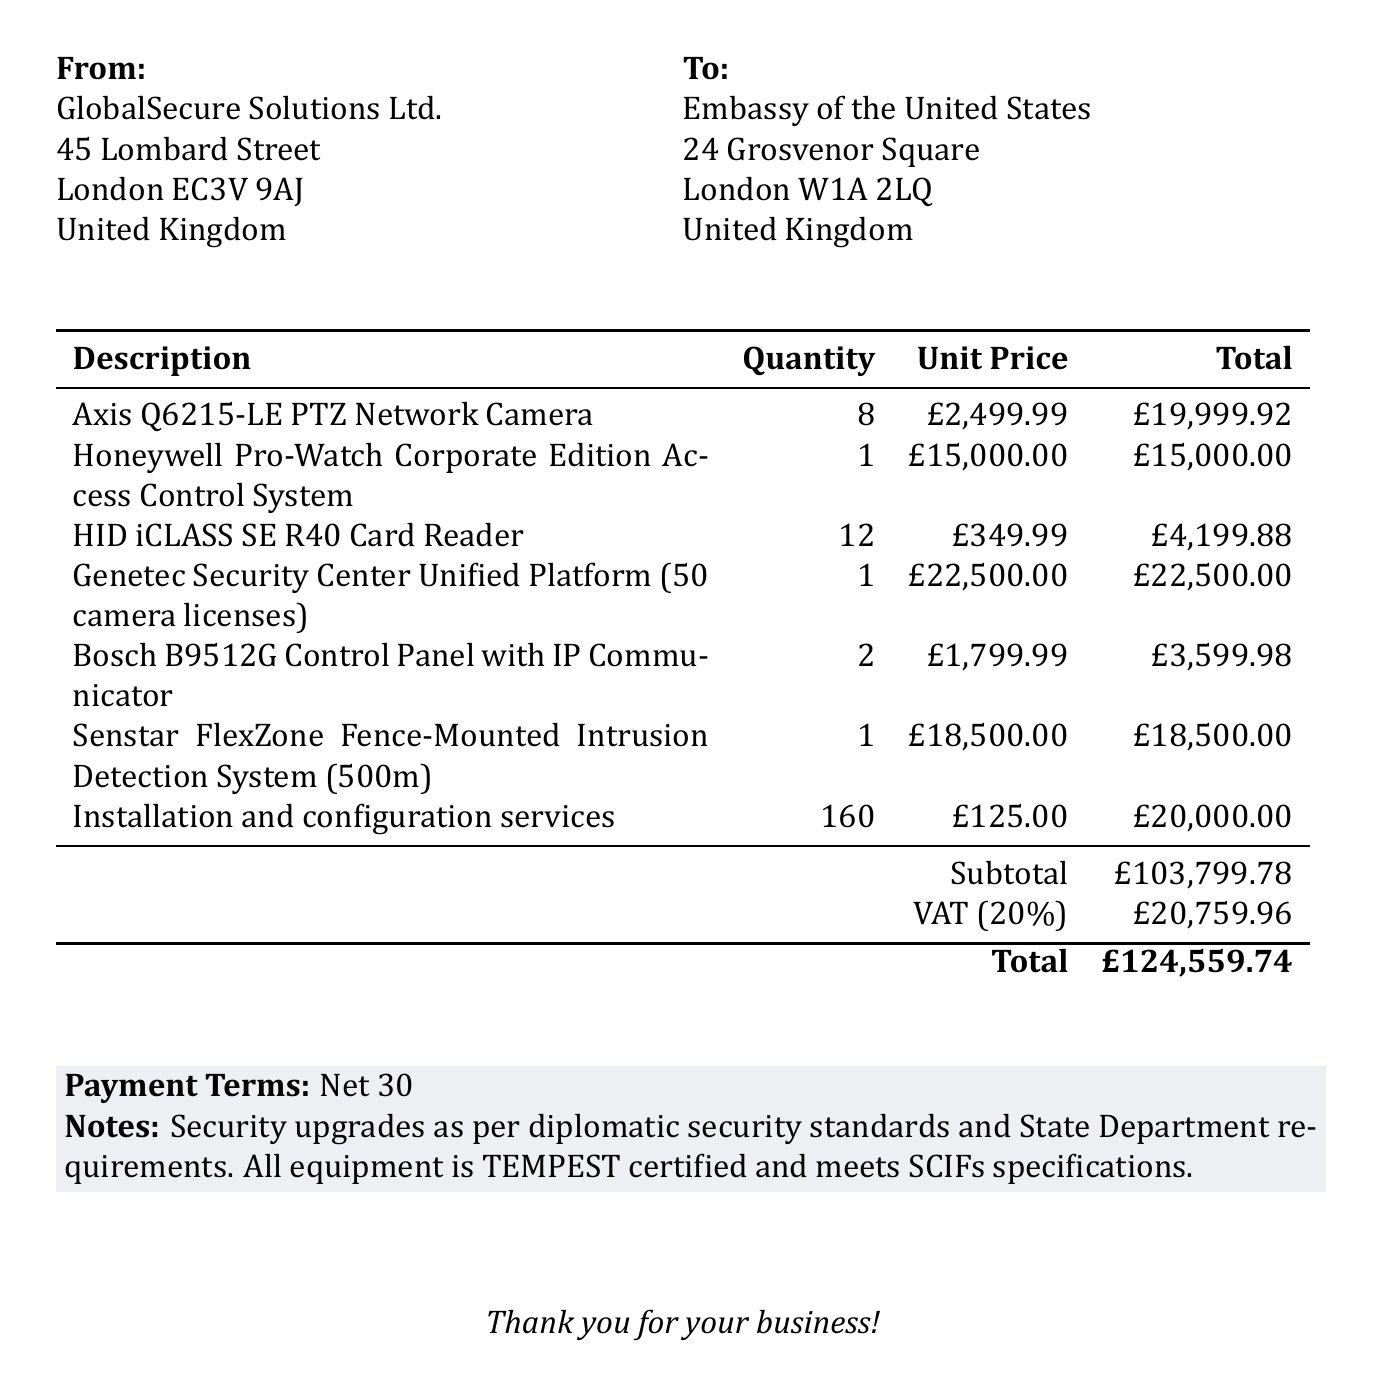what is the invoice number? The invoice number is prominently stated in the document, identifying this specific transaction.
Answer: INV-2023-0542 what is the date of the invoice? The date is mentioned alongside the invoice number, indicating when the invoice was issued.
Answer: 2023-05-15 who is the vendor? The vendor's name is listed at the top of the invoice, indicating the company providing the services and equipment.
Answer: GlobalSecure Solutions Ltd what is the total amount due? The total amount is calculated by summing the subtotal and tax amounts, clearly stated at the bottom of the invoice.
Answer: £124,559.74 how many Axis Q6215-LE Cameras are ordered? The quantity of these specific cameras is specified in the item list part of the invoice.
Answer: 8 what is the subtotal amount before tax? The subtotal is provided just above the tax amount in the summary section of the invoice.
Answer: £103,799.78 what are the payment terms? Payment terms are usually listed at the bottom of the invoice, outlining when payment is expected.
Answer: Net 30 how many items are listed in the invoice? The total number of items can be counted from the items table presented in the document.
Answer: 7 what is the tax rate applied? The tax rate is indicated to provide clarity on the taxation applied to the subtotal amount.
Answer: 20% 